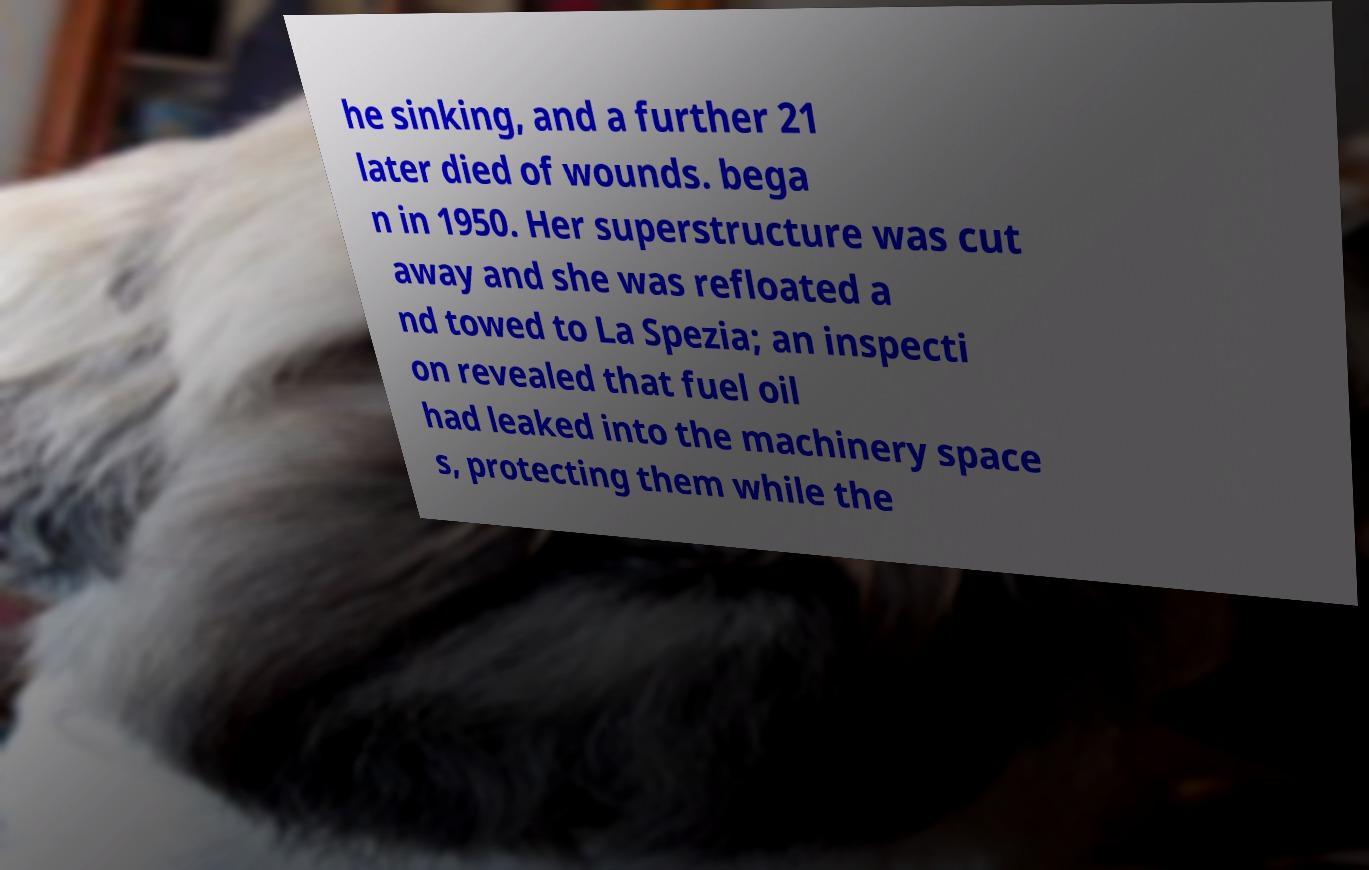Please read and relay the text visible in this image. What does it say? he sinking, and a further 21 later died of wounds. bega n in 1950. Her superstructure was cut away and she was refloated a nd towed to La Spezia; an inspecti on revealed that fuel oil had leaked into the machinery space s, protecting them while the 